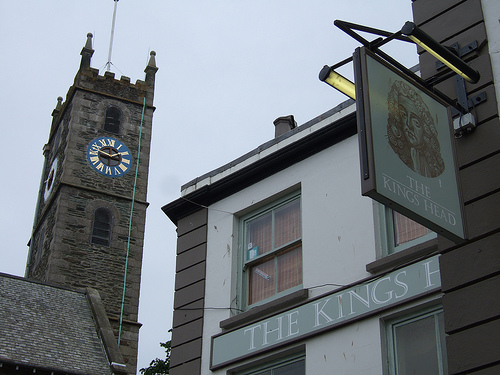Does the window of the building look curved? Yes, the top window in the image has a unique curvature that adds a charming architectural element to the building's facade. 